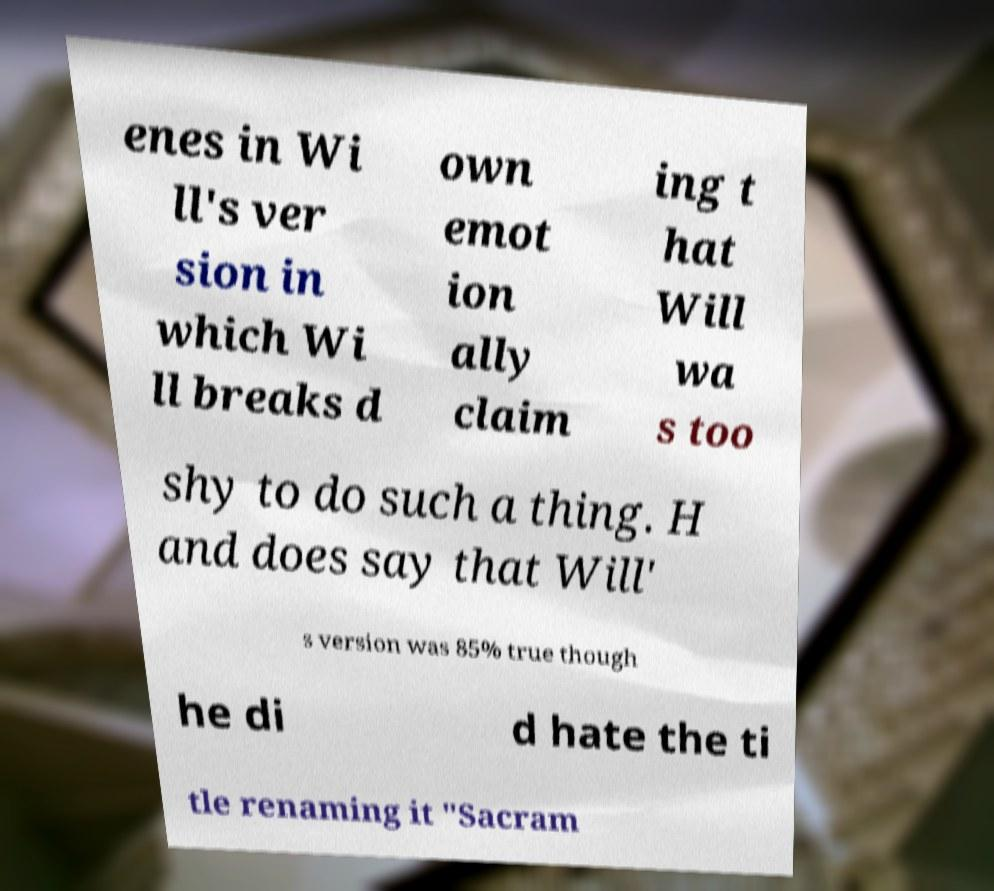Can you read and provide the text displayed in the image?This photo seems to have some interesting text. Can you extract and type it out for me? enes in Wi ll's ver sion in which Wi ll breaks d own emot ion ally claim ing t hat Will wa s too shy to do such a thing. H and does say that Will' s version was 85% true though he di d hate the ti tle renaming it "Sacram 